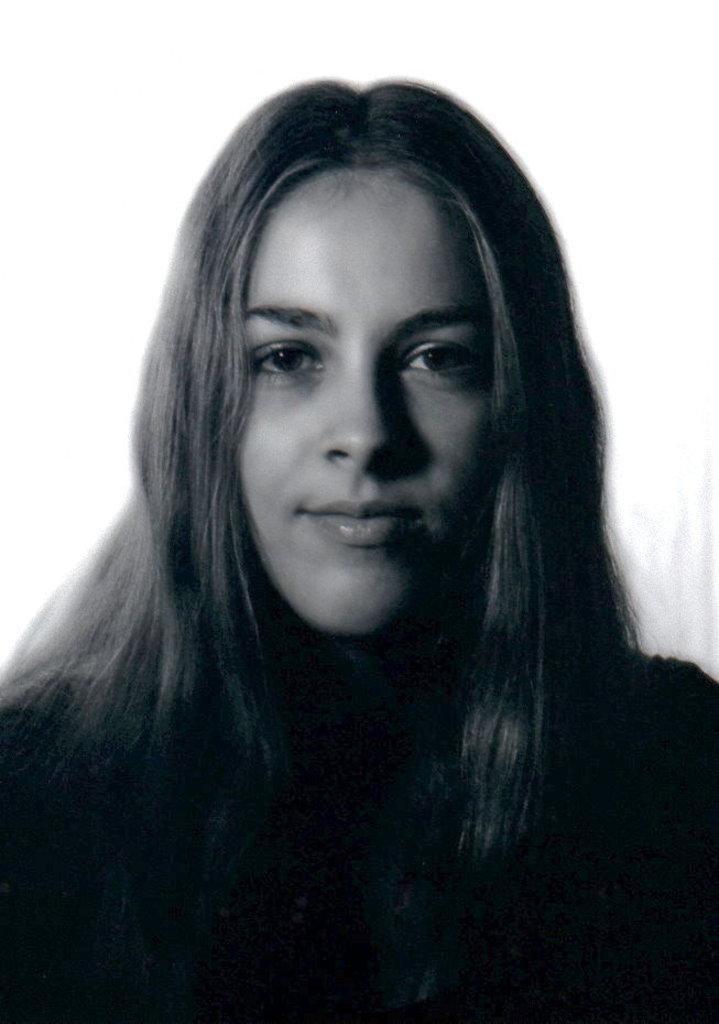In one or two sentences, can you explain what this image depicts? In this image I can see the person wearing the dress and this is a black and white image. 